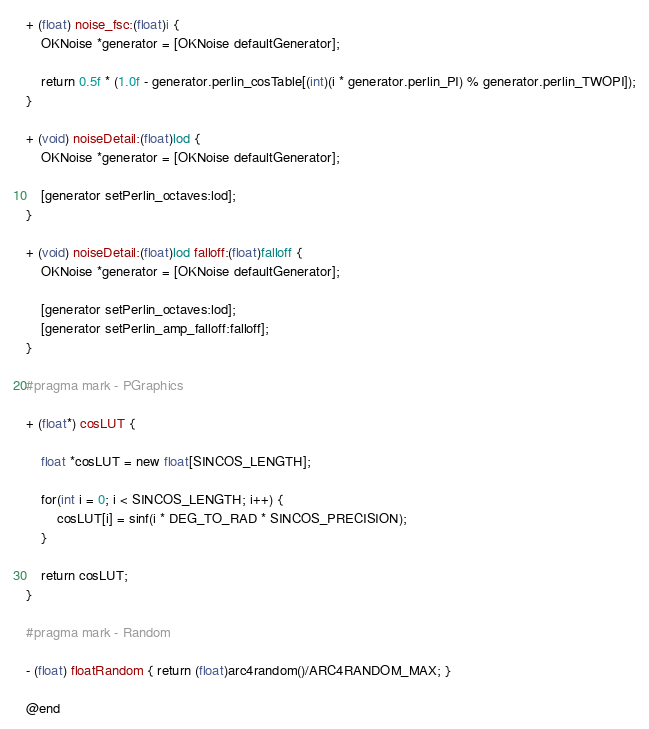<code> <loc_0><loc_0><loc_500><loc_500><_ObjectiveC_>
+ (float) noise_fsc:(float)i {
    OKNoise *generator = [OKNoise defaultGenerator];
    
    return 0.5f * (1.0f - generator.perlin_cosTable[(int)(i * generator.perlin_PI) % generator.perlin_TWOPI]);
}

+ (void) noiseDetail:(float)lod {
    OKNoise *generator = [OKNoise defaultGenerator];
    
    [generator setPerlin_octaves:lod];
}

+ (void) noiseDetail:(float)lod falloff:(float)falloff {
    OKNoise *generator = [OKNoise defaultGenerator];
    
    [generator setPerlin_octaves:lod];
    [generator setPerlin_amp_falloff:falloff];
}

#pragma mark - PGraphics

+ (float*) cosLUT {
    
    float *cosLUT = new float[SINCOS_LENGTH];
    
    for(int i = 0; i < SINCOS_LENGTH; i++) {
        cosLUT[i] = sinf(i * DEG_TO_RAD * SINCOS_PRECISION);
    }
    
    return cosLUT;
}

#pragma mark - Random

- (float) floatRandom { return (float)arc4random()/ARC4RANDOM_MAX; }

@end

</code> 